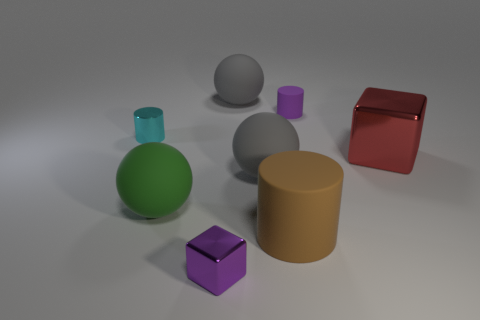Subtract all small cyan shiny cylinders. How many cylinders are left? 2 Add 1 yellow blocks. How many objects exist? 9 Subtract all cubes. How many objects are left? 6 Add 6 brown cylinders. How many brown cylinders are left? 7 Add 1 big matte things. How many big matte things exist? 5 Subtract 0 gray cylinders. How many objects are left? 8 Subtract all brown blocks. Subtract all small things. How many objects are left? 5 